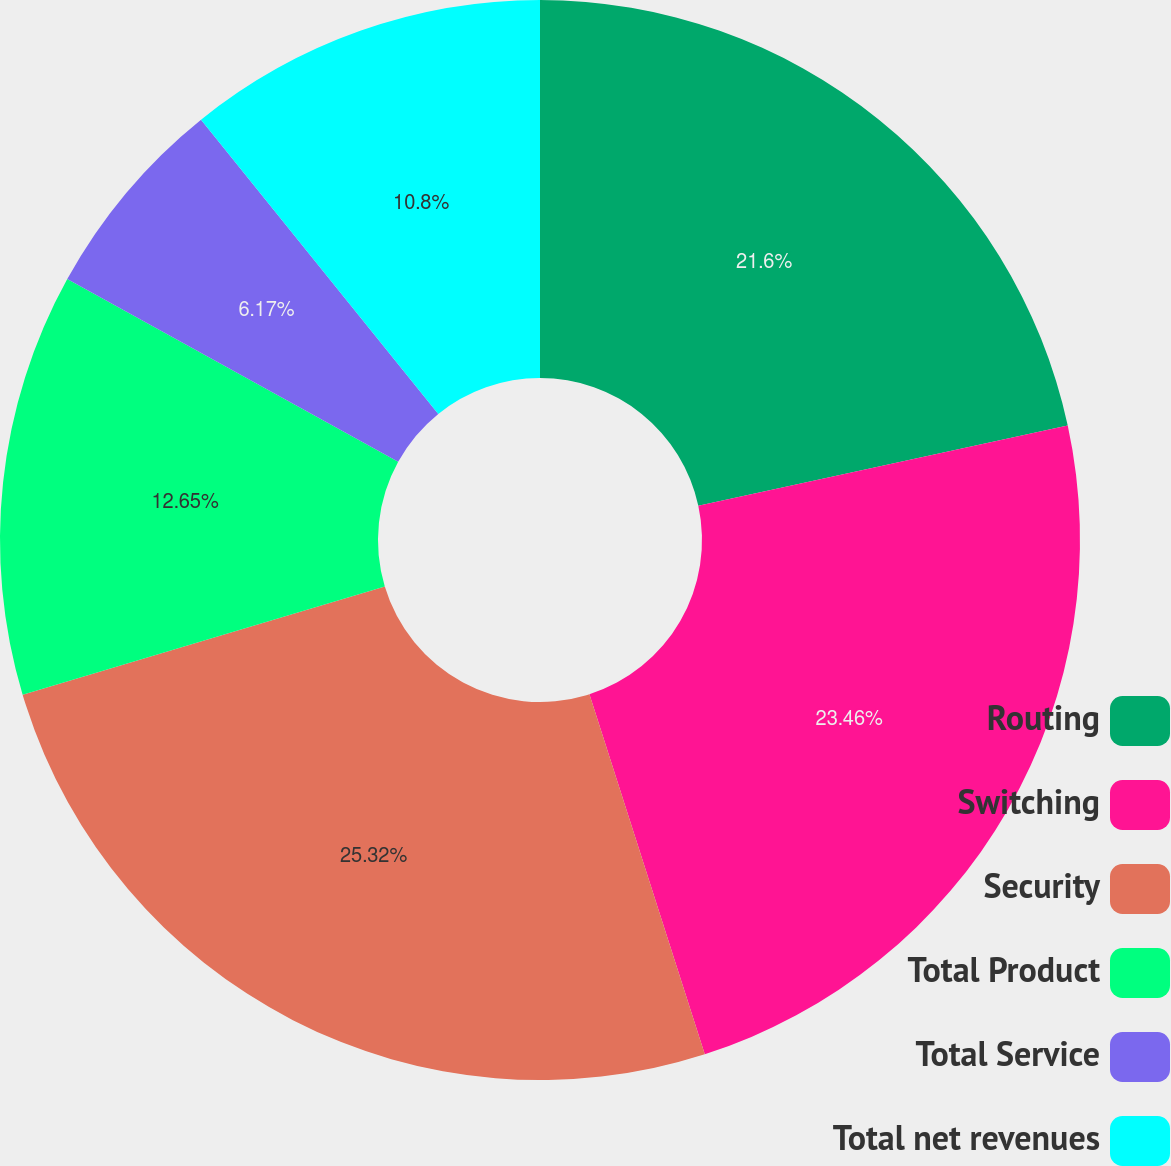<chart> <loc_0><loc_0><loc_500><loc_500><pie_chart><fcel>Routing<fcel>Switching<fcel>Security<fcel>Total Product<fcel>Total Service<fcel>Total net revenues<nl><fcel>21.6%<fcel>23.46%<fcel>25.31%<fcel>12.65%<fcel>6.17%<fcel>10.8%<nl></chart> 